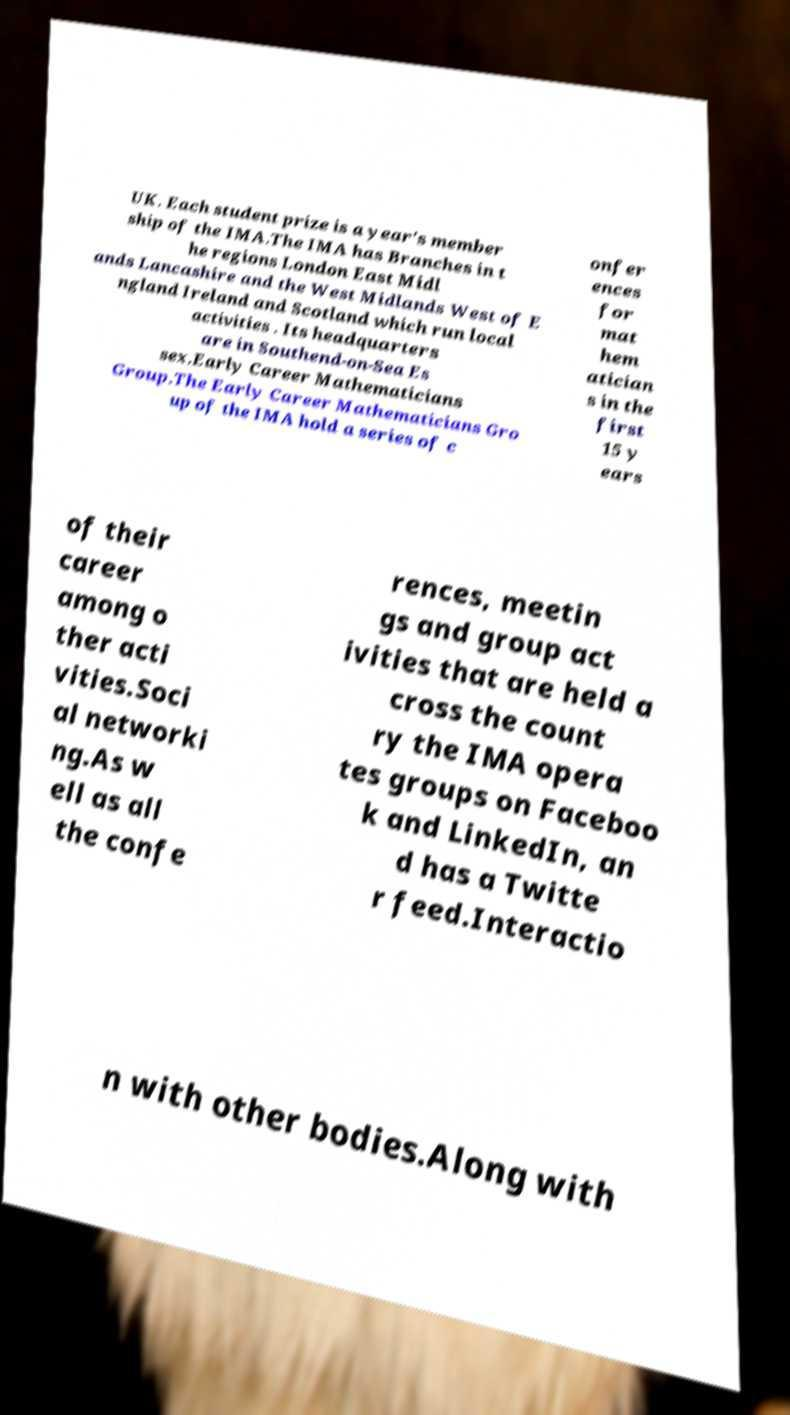Please identify and transcribe the text found in this image. UK. Each student prize is a year's member ship of the IMA.The IMA has Branches in t he regions London East Midl ands Lancashire and the West Midlands West of E ngland Ireland and Scotland which run local activities . Its headquarters are in Southend-on-Sea Es sex.Early Career Mathematicians Group.The Early Career Mathematicians Gro up of the IMA hold a series of c onfer ences for mat hem atician s in the first 15 y ears of their career among o ther acti vities.Soci al networki ng.As w ell as all the confe rences, meetin gs and group act ivities that are held a cross the count ry the IMA opera tes groups on Faceboo k and LinkedIn, an d has a Twitte r feed.Interactio n with other bodies.Along with 